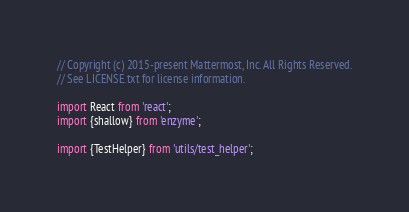<code> <loc_0><loc_0><loc_500><loc_500><_TypeScript_>// Copyright (c) 2015-present Mattermost, Inc. All Rights Reserved.
// See LICENSE.txt for license information.

import React from 'react';
import {shallow} from 'enzyme';

import {TestHelper} from 'utils/test_helper';
</code> 